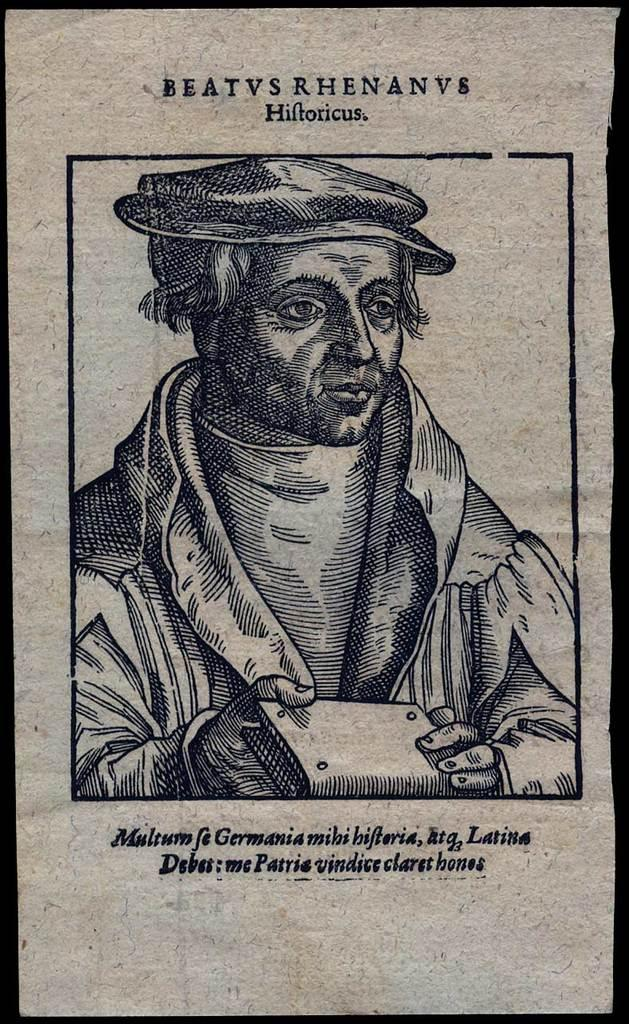What is the main subject of the image? There is a person in the image. What is the person wearing on their head? The person is wearing a cap. What is the person holding in their hands? The person is holding a book. Can you describe any text or writing in the image? Yes, there is writing on the image. How many bombs can be seen in the image? There are no bombs present in the image. What type of nose is visible on the person in the image? There is no nose visible on the person in the image, as the person is wearing a cap that covers their head. --- Facts: 1. There is a car in the image. 2. The car is red. 3. The car has four wheels. 4. There is a road in the image. 5. The road is paved. Absurd Topics: bird, ocean, mountain Conversation: What is the main subject of the image? There is a car in the image. What color is the car? The car is red. How many wheels does the car have? The car has four wheels. What type of surface is the car on? There is a road in the image, and it is paved. Reasoning: Let's think step by step in order to produce the conversation. We start by identifying the main subject of the image, which is the car. Then, we describe specific details about the car, such as its color and the number of wheels. Finally, we acknowledge the presence of a road and describe its surface. Absurd Question/Answer: Can you see any birds flying over the ocean in the image? There is no ocean or birds present in the image; it features a red car on a paved road. What type of mountain range is visible in the background of the image? There is no mountain range visible in the image; it features a red car on a paved road. 